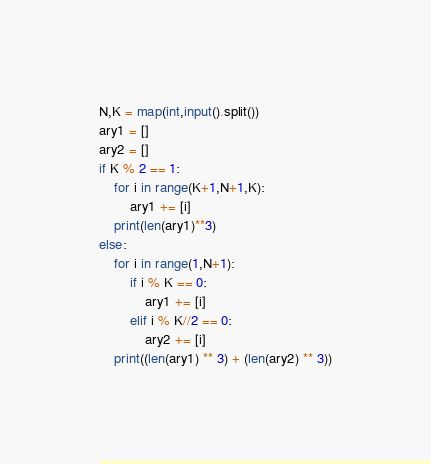<code> <loc_0><loc_0><loc_500><loc_500><_Python_>N,K = map(int,input().split())
ary1 = []
ary2 = []
if K % 2 == 1:
    for i in range(K+1,N+1,K):
        ary1 += [i]
    print(len(ary1)**3)
else:
    for i in range(1,N+1):
        if i % K == 0:
            ary1 += [i]
        elif i % K//2 == 0:
            ary2 += [i]
    print((len(ary1) ** 3) + (len(ary2) ** 3))
</code> 